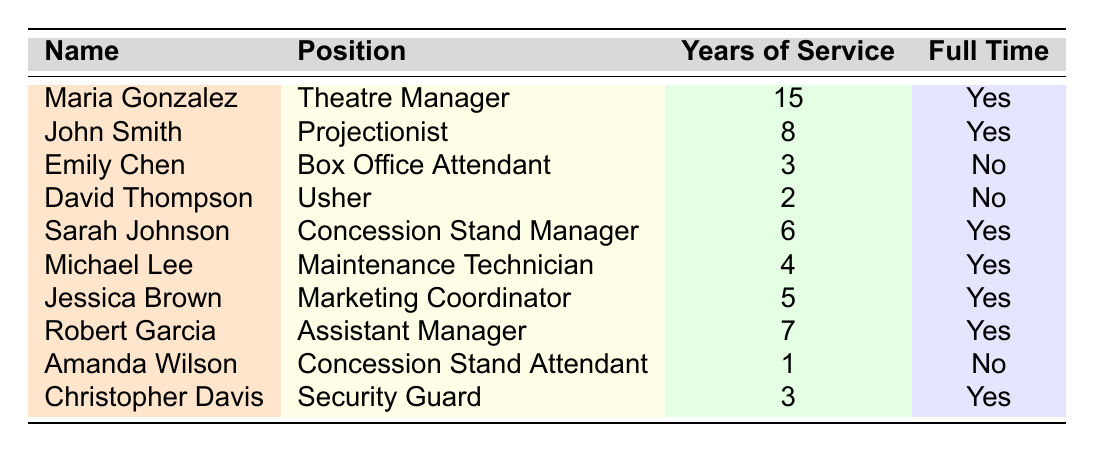What is the position of Maria Gonzalez? According to the table, Maria Gonzalez is listed under the position of Theatre Manager.
Answer: Theatre Manager How many years of service does John Smith have? The table indicates that John Smith has 8 years of service in his position as a Projectionist.
Answer: 8 Is Emily Chen a full-time employee? Emily Chen's employment status is noted in the table as part-time (No).
Answer: No Who is the Concession Stand Manager, and how many years of service do they have? The table shows that Sarah Johnson is the Concession Stand Manager, and she has 6 years of service.
Answer: Sarah Johnson, 6 years How many full-time employees are on the staff roster? By reviewing the table, we can see that there are 6 full-time employees: Maria Gonzalez, John Smith, Sarah Johnson, Michael Lee, Jessica Brown, and Robert Garcia.
Answer: 6 What is the average years of service of all staff members? Adding the years of service: 15 + 8 + 3 + 2 + 6 + 4 + 5 + 7 + 1 + 3 = 54. There are 10 staff members, so the average is 54/10 = 5.4 years.
Answer: 5.4 Is there anyone with less than 2 years of service? The table shows that David Thompson has 2 years of service, and Amanda Wilson has only 1 year, which qualifies as less than 2 years.
Answer: Yes What percentage of employees are full-time? There are 10 employees in total, with 6 being full-time. The percentage is calculated by (6/10) * 100 = 60%.
Answer: 60% Who has the longest tenure at the Rio Theatre and how long have they served? By looking at the year of service for each employee, Maria Gonzalez has served the longest with 15 years.
Answer: Maria Gonzalez, 15 years If we exclude part-time employees, what is the minimum years of service among full-time employees? The full-time employees are Maria Gonzalez (15), John Smith (8), Sarah Johnson (6), Michael Lee (4), Jessica Brown (5), and Robert Garcia (7). The minimum among these is 4 years from Michael Lee.
Answer: 4 